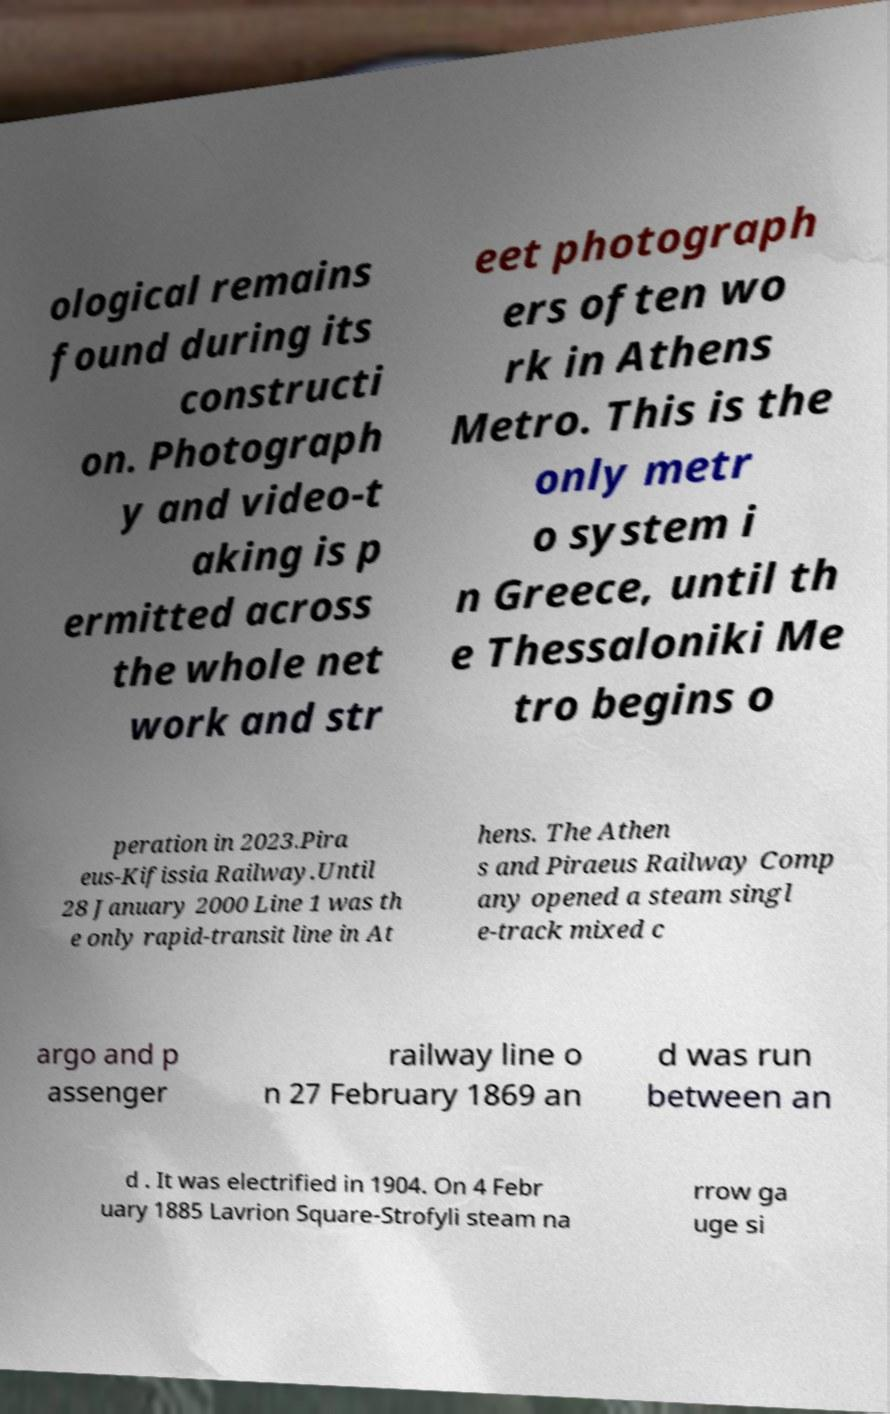For documentation purposes, I need the text within this image transcribed. Could you provide that? ological remains found during its constructi on. Photograph y and video-t aking is p ermitted across the whole net work and str eet photograph ers often wo rk in Athens Metro. This is the only metr o system i n Greece, until th e Thessaloniki Me tro begins o peration in 2023.Pira eus-Kifissia Railway.Until 28 January 2000 Line 1 was th e only rapid-transit line in At hens. The Athen s and Piraeus Railway Comp any opened a steam singl e-track mixed c argo and p assenger railway line o n 27 February 1869 an d was run between an d . It was electrified in 1904. On 4 Febr uary 1885 Lavrion Square-Strofyli steam na rrow ga uge si 